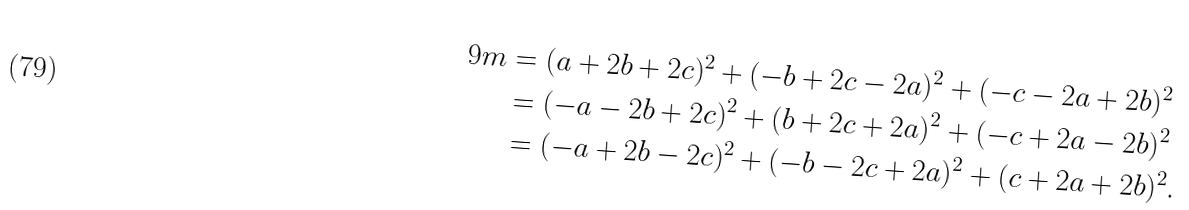Convert formula to latex. <formula><loc_0><loc_0><loc_500><loc_500>9 m & = ( a + 2 b + 2 c ) ^ { 2 } + ( - b + 2 c - 2 a ) ^ { 2 } + ( - c - 2 a + 2 b ) ^ { 2 } \\ & = ( - a - 2 b + 2 c ) ^ { 2 } + ( b + 2 c + 2 a ) ^ { 2 } + ( - c + 2 a - 2 b ) ^ { 2 } \\ & = ( - a + 2 b - 2 c ) ^ { 2 } + ( - b - 2 c + 2 a ) ^ { 2 } + ( c + 2 a + 2 b ) ^ { 2 } .</formula> 